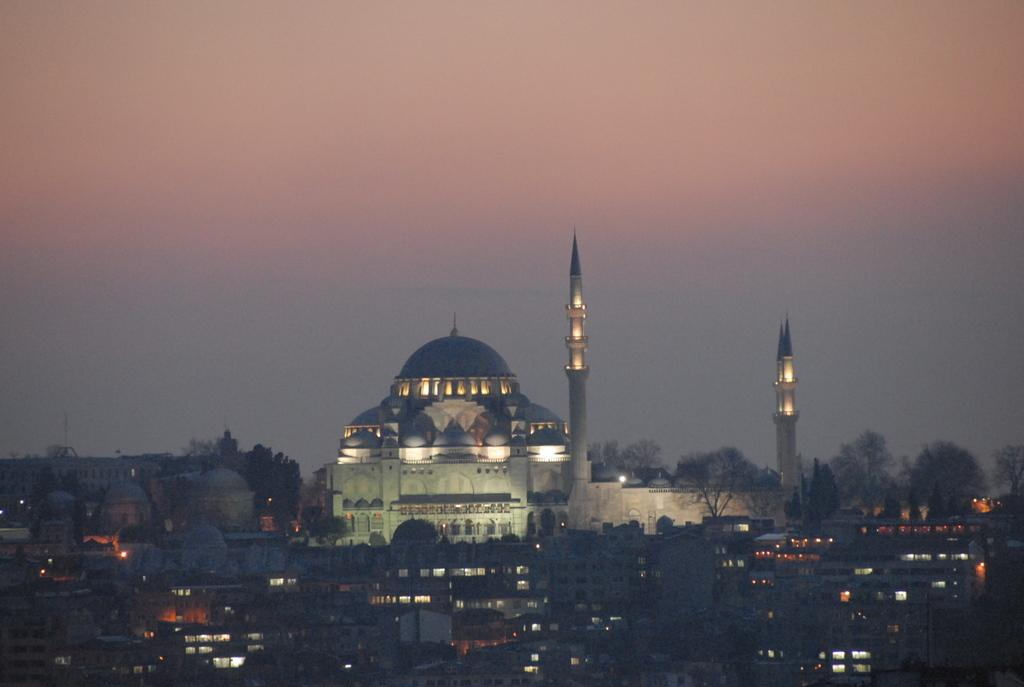What type of structures can be seen in the image? There are buildings in the image. Can you describe one of the buildings in more detail? One of the buildings is white. What else is visible in the image besides the buildings? There are lights visible in the image. What can be seen in the background of the image? The sky is visible in the background of the image. What type of goose is sitting on the dinner table in the image? There is no goose or dinner table present in the image. How many leaves are on the tree in the image? There is no tree or leaves present in the image. 